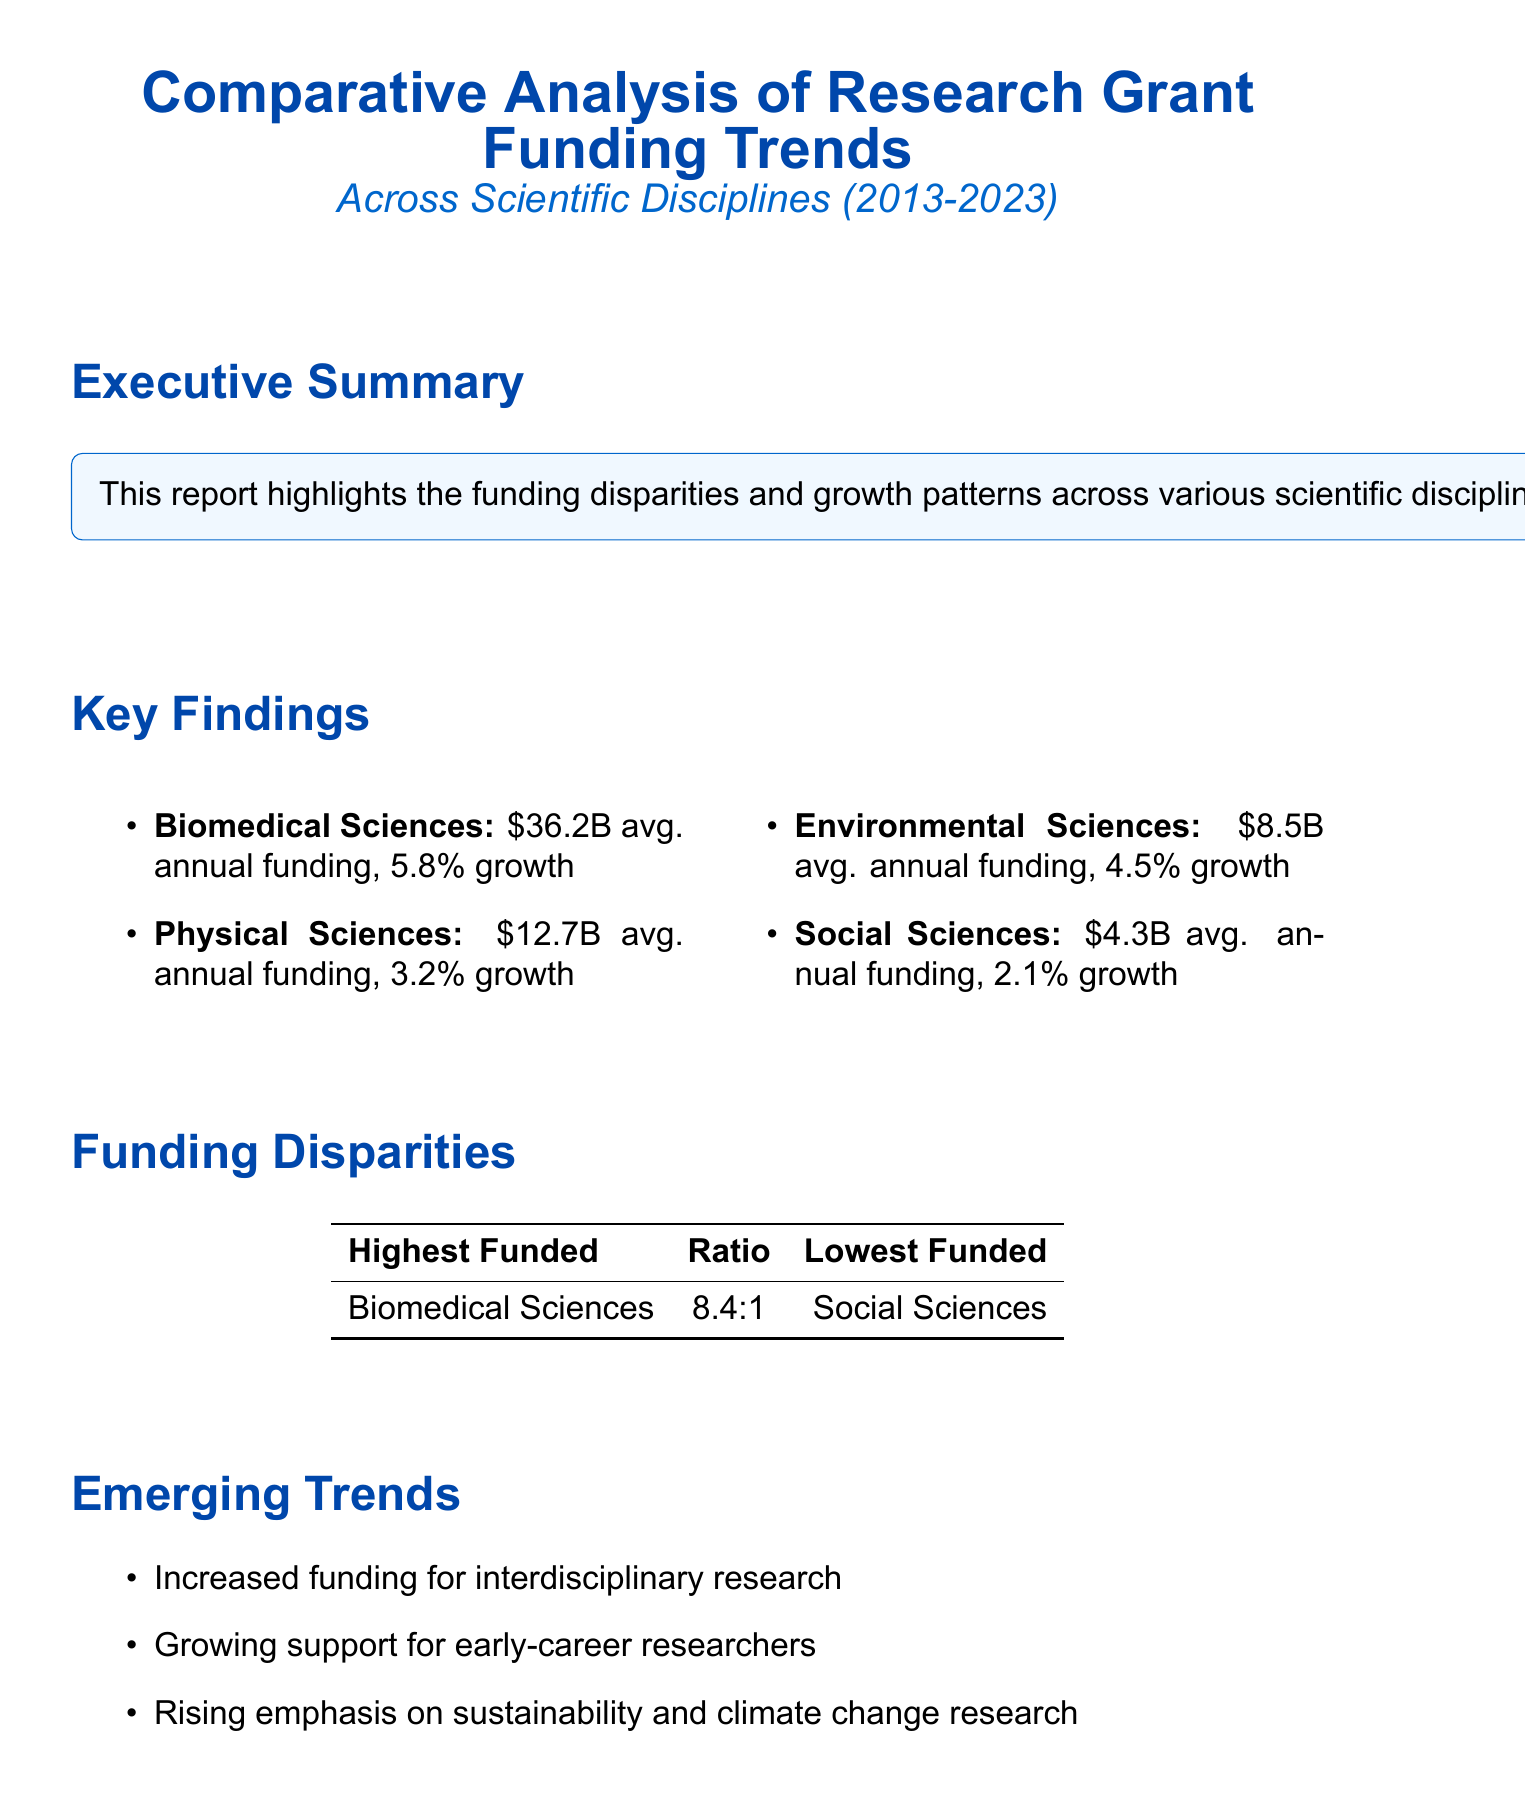What is the average annual funding for Biomedical Sciences? The average annual funding for Biomedical Sciences is specified in the key findings section of the document as $36.2 billion.
Answer: $36.2 billion Which funding agency is the top funder for Physical Sciences? The top funding agency for Physical Sciences is mentioned in the key findings section of the document, which is the Department of Energy (DOE).
Answer: Department of Energy (DOE) What is the growth rate of funding in Social Sciences? The growth rate of funding in Social Sciences is detailed in the key findings section of the document as 2.1% per year.
Answer: 2.1% per year What is the funding disparity ratio between the highest and lowest funded disciplines? The funding disparity ratio is explicitly provided in the funding disparities section of the document as 8.4:1.
Answer: 8.4:1 What emerging trend emphasizes support for early-career researchers? An item under the emerging trends section mentions "Growing support for early-career researchers" as a trend identified in the report.
Answer: Growing support for early-career researchers How much is the estimated contribution of research funding to U.S. GDP in 2023? The estimated contribution to U.S. GDP is provided in the economic impact section of the document as $865 billion.
Answer: $865 billion What increase in overall research grant funding is recommended? The recommendation section suggests a "15% increase in overall research grant funding across all disciplines."
Answer: 15% What is the highest funded discipline according to the report? The highest funded discipline is explicitly stated in the funding disparities section of the document as Biomedical Sciences.
Answer: Biomedical Sciences 